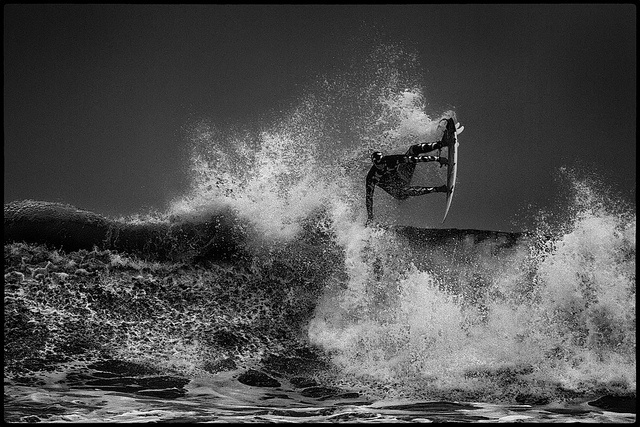Describe the objects in this image and their specific colors. I can see people in black, gray, and lightgray tones and surfboard in black, gray, darkgray, and lightgray tones in this image. 